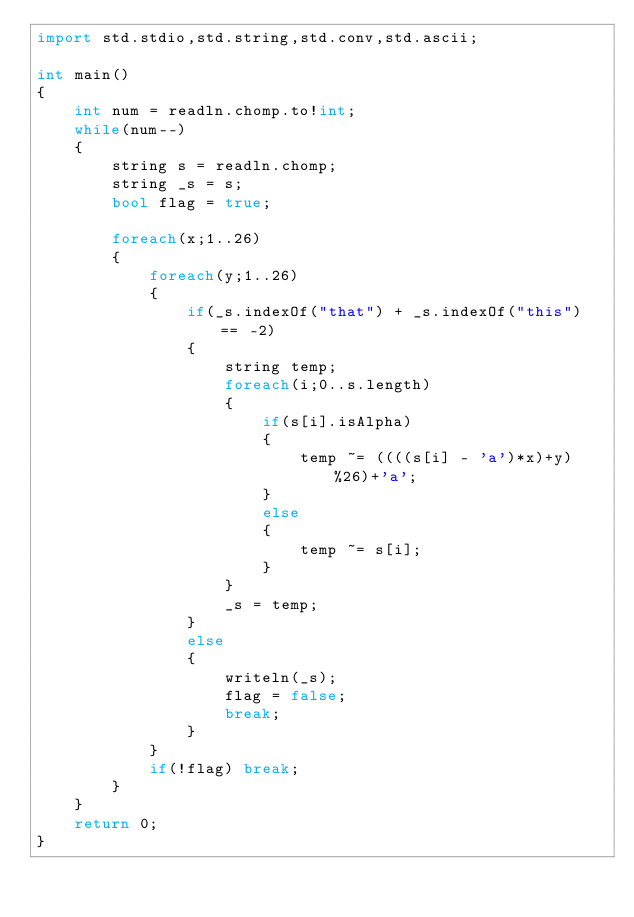Convert code to text. <code><loc_0><loc_0><loc_500><loc_500><_D_>import std.stdio,std.string,std.conv,std.ascii;

int main()
{
	int num = readln.chomp.to!int;
	while(num--)
	{
		string s = readln.chomp;
		string _s = s;
		bool flag = true;

		foreach(x;1..26)
		{
			foreach(y;1..26)
			{
				if(_s.indexOf("that") + _s.indexOf("this") == -2)
				{
					string temp;
					foreach(i;0..s.length)
					{
						if(s[i].isAlpha)
						{
							temp ~= ((((s[i] - 'a')*x)+y)%26)+'a';
						}
						else
						{
							temp ~= s[i];
						}
					}
					_s = temp;
				}
				else
				{
					writeln(_s);
					flag = false;
					break;
				}
			}
			if(!flag) break;
		}
	}
	return 0;
}</code> 